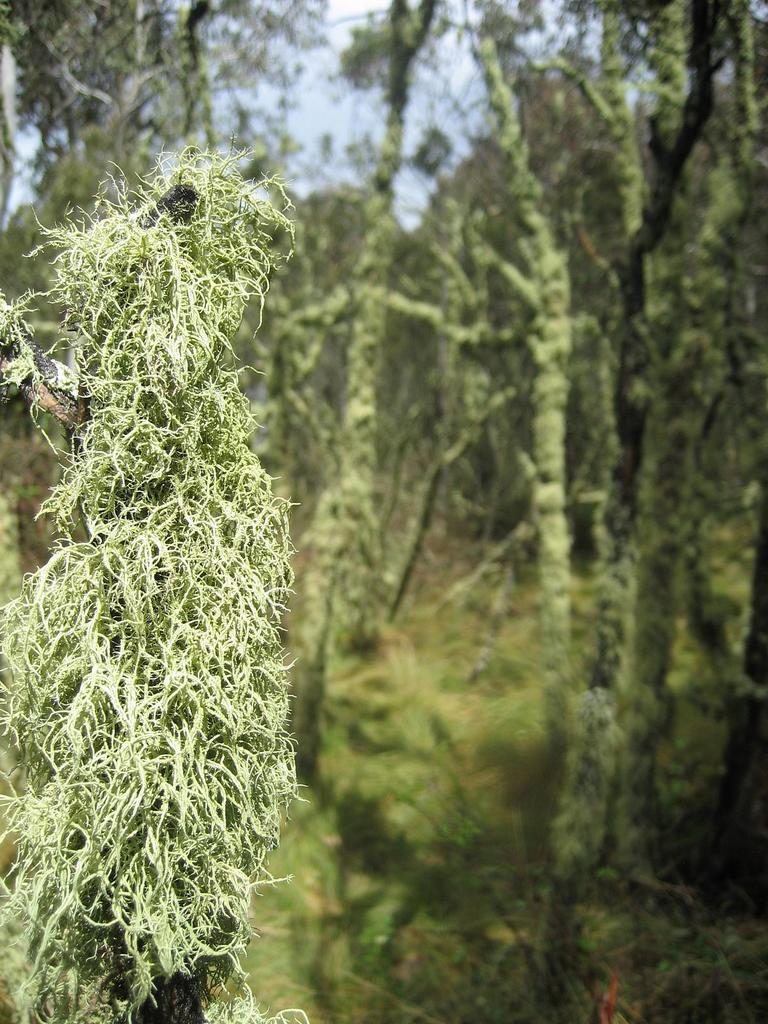Can you describe this image briefly? In this image I can see few trees which are green in color. In the background I can see the sky. 